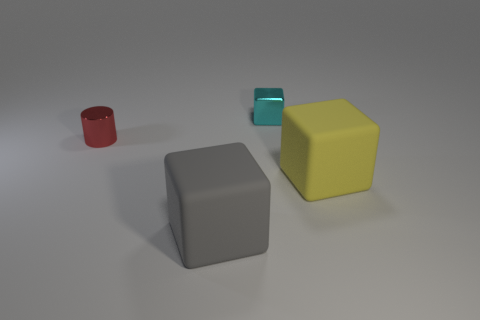Are any large green shiny spheres visible?
Ensure brevity in your answer.  No. How many other objects are there of the same size as the gray object?
Offer a terse response. 1. The yellow rubber thing that is the same shape as the gray matte thing is what size?
Keep it short and to the point. Large. Is the cube that is to the right of the small cyan block made of the same material as the thing in front of the big yellow cube?
Your answer should be compact. Yes. What number of metal objects are big cubes or small red cylinders?
Provide a short and direct response. 1. What material is the small object on the right side of the gray rubber object that is on the left side of the big block to the right of the small cube?
Make the answer very short. Metal. Does the tiny metal thing that is behind the red object have the same shape as the big rubber thing on the left side of the tiny cyan shiny cube?
Ensure brevity in your answer.  Yes. There is a big matte thing that is on the left side of the tiny object that is to the right of the red object; what is its color?
Make the answer very short. Gray. What number of cylinders are either blue things or rubber objects?
Provide a short and direct response. 0. What number of red cylinders are in front of the small thing that is on the right side of the metallic thing that is on the left side of the gray cube?
Give a very brief answer. 1. 